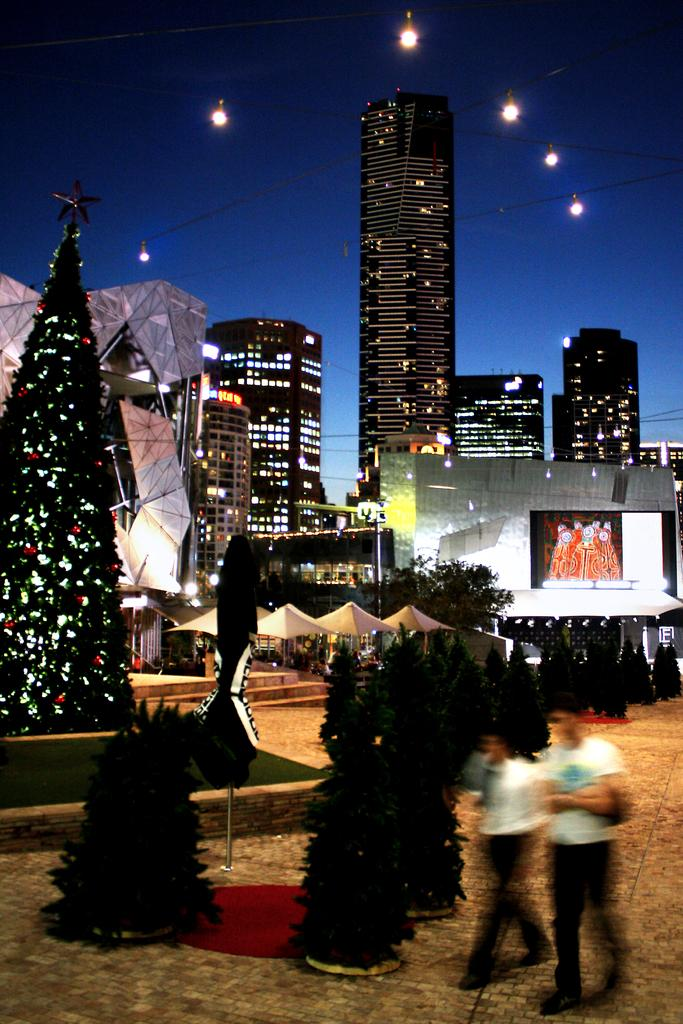What are the two people in the image doing? The two people in the image are walking. On what surface are the people walking? The people are walking on a pavement. What can be seen in the background of the image? In the background of the image, there are Christmas trees, buildings, lights, and the sky. Where are the ducks swimming in the image? There are no ducks present in the image. What type of garden can be seen in the background of the image? There is no garden visible in the background of the image. 